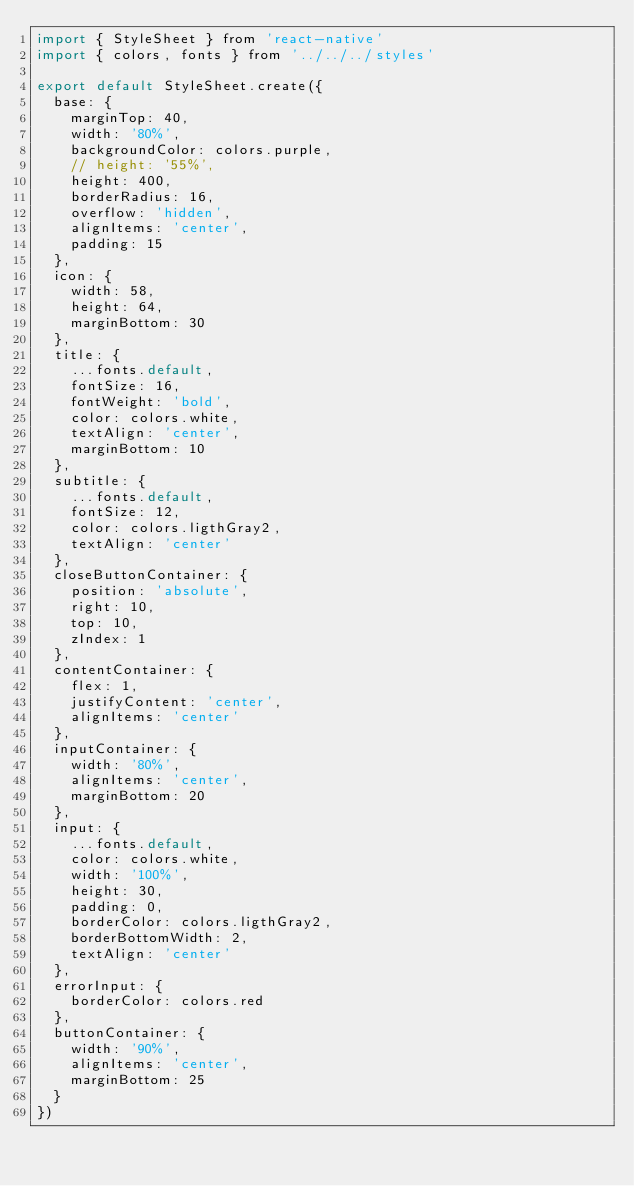<code> <loc_0><loc_0><loc_500><loc_500><_JavaScript_>import { StyleSheet } from 'react-native'
import { colors, fonts } from '../../../styles'

export default StyleSheet.create({
  base: {
    marginTop: 40,
    width: '80%',
    backgroundColor: colors.purple,
    // height: '55%',
    height: 400,
    borderRadius: 16,
    overflow: 'hidden',
    alignItems: 'center',
    padding: 15
  },
  icon: {
    width: 58,
    height: 64,
    marginBottom: 30
  },
  title: {
    ...fonts.default,
    fontSize: 16,
    fontWeight: 'bold',
    color: colors.white,
    textAlign: 'center',
    marginBottom: 10
  },
  subtitle: {
    ...fonts.default,
    fontSize: 12,
    color: colors.ligthGray2,
    textAlign: 'center'
  },
  closeButtonContainer: {
    position: 'absolute',
    right: 10,
    top: 10,
    zIndex: 1
  },
  contentContainer: {
    flex: 1,
    justifyContent: 'center',
    alignItems: 'center'
  },
  inputContainer: {
    width: '80%',
    alignItems: 'center',
    marginBottom: 20
  },
  input: {
    ...fonts.default,
    color: colors.white,
    width: '100%',
    height: 30,
    padding: 0,
    borderColor: colors.ligthGray2,
    borderBottomWidth: 2,
    textAlign: 'center'
  },
  errorInput: {
    borderColor: colors.red
  },
  buttonContainer: {
    width: '90%',
    alignItems: 'center',
    marginBottom: 25
  }
})
</code> 